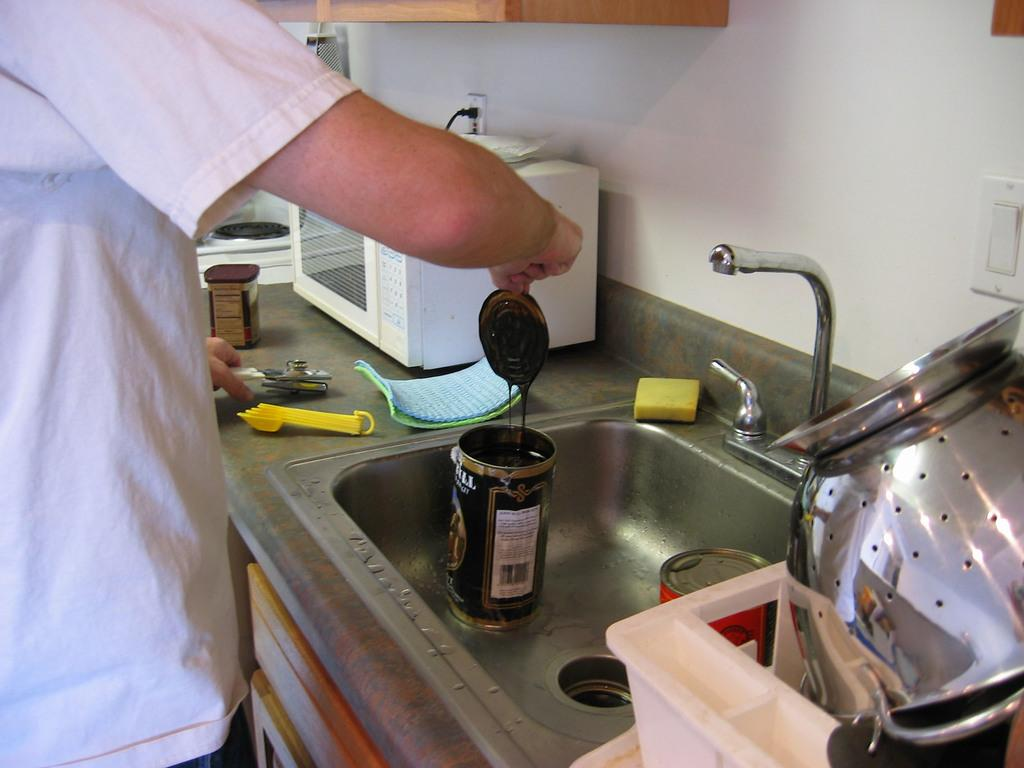What is the person in the image holding? The person is holding a bottle cap in the image. What can be seen in the wash basin in the image? There are two bottles in a wash basin in the image. Can you describe any other objects present in the image? There are some other objects in the image, but their specific details are not mentioned in the provided facts. What type of nail is the person using to exchange messages with the cat in the image? There is no nail or cat present in the image; the person is holding a bottle cap, and there are two bottles in a wash basin. 